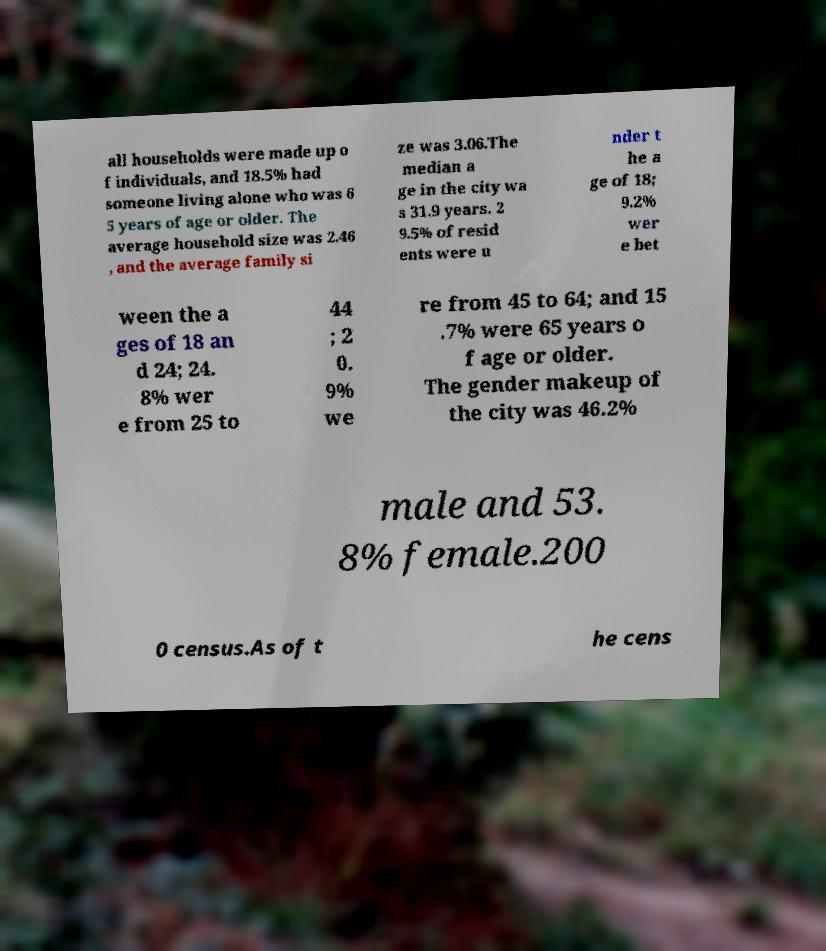Please identify and transcribe the text found in this image. all households were made up o f individuals, and 18.5% had someone living alone who was 6 5 years of age or older. The average household size was 2.46 , and the average family si ze was 3.06.The median a ge in the city wa s 31.9 years. 2 9.5% of resid ents were u nder t he a ge of 18; 9.2% wer e bet ween the a ges of 18 an d 24; 24. 8% wer e from 25 to 44 ; 2 0. 9% we re from 45 to 64; and 15 .7% were 65 years o f age or older. The gender makeup of the city was 46.2% male and 53. 8% female.200 0 census.As of t he cens 